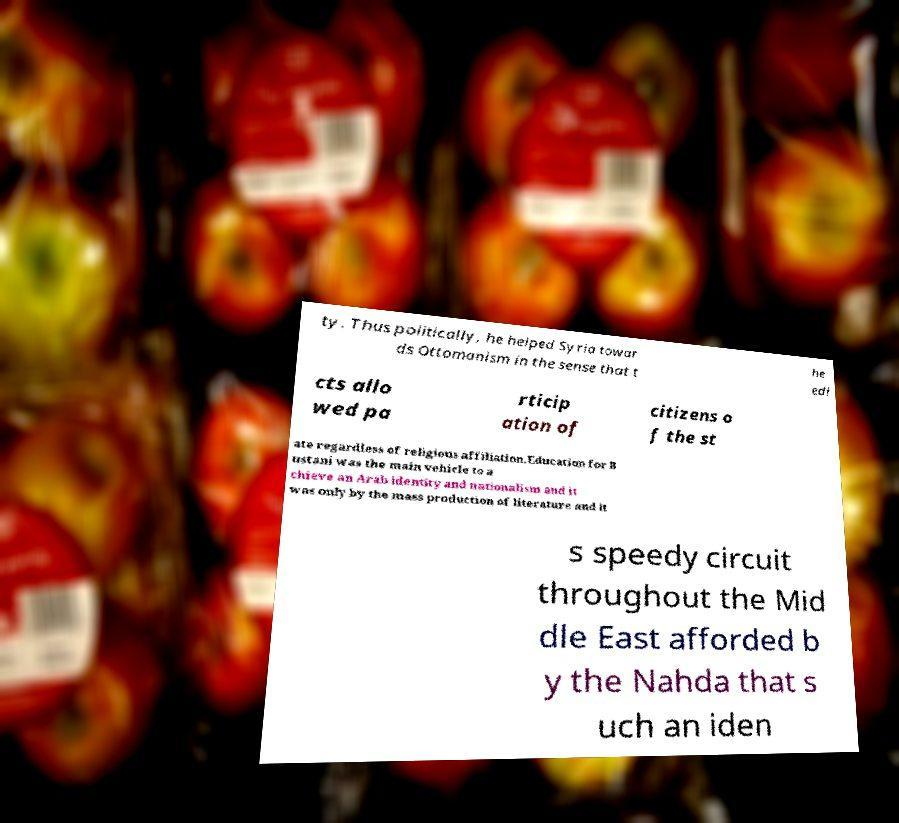Can you read and provide the text displayed in the image?This photo seems to have some interesting text. Can you extract and type it out for me? ty. Thus politically, he helped Syria towar ds Ottomanism in the sense that t he edi cts allo wed pa rticip ation of citizens o f the st ate regardless of religious affiliation.Education for B ustani was the main vehicle to a chieve an Arab identity and nationalism and it was only by the mass production of literature and it s speedy circuit throughout the Mid dle East afforded b y the Nahda that s uch an iden 